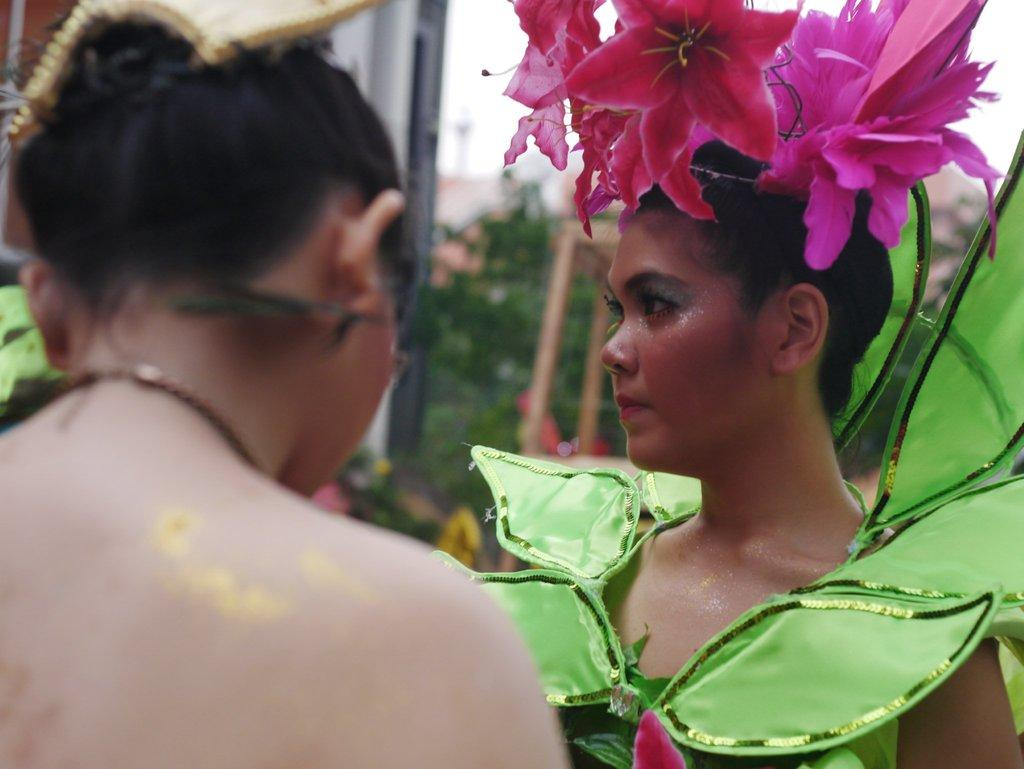What type of people can be seen in the image? There are women standing in the image. What is unique about the appearance of some of the women? Artificial flowers are on the heads of some women. What type of structures are visible in the image? There are buildings visible in the image. What type of vegetation is present in the image? Trees are present in the image. What type of basketball is being played in the image? There is no basketball being played in the image. --- Facts: 1. There is a person in the image. 2. The person is wearing a hat. 3. The person is holding a book. 4. There is a table in the image. 5. There is a chair in the image. Absurd Topics: elephant, piano, ocean Conversation: What is the main subject in the image? There is a person in the image. What is the person wearing on their head? The person is wearing a hat. What is the person holding in their hands? The person is holding a book. What type of furniture is present in the image? There is a table and a chair in the image. Reasoning: Let's think step by step in order to produce the conversation. We start by identifying the main subject of the image, which is the person. Next, we describe specific features of the person, such as the hat. Then, we observe the actions of the person, noting that they are holding a book. Finally, we describe the furniture present in the image, which includes a table and a chair. Absurd Question/Answer: What type of musical instrument can be seen being played in the image? There is no musical instrument being played in the image. --- Facts: 1. There is a group of people in the image. 2. The people are wearing matching outfits. 3. The people are standing in front of a mountain. 4. There is a river flowing in the background. 5. The sky is visible and has a blue color. Absurd Topics: lion, castle, moon Conversation: How many people are present in the image? There is a group of people in the image. What are the people wearing in the image? The people are wearing matching outfits. What type of natural landscape is visible in the image? The people are standing in front of a mountain. What type of water body is present in the background of the image? There is a river flowing in the background. What is the color of the sky visible in the image? The sky is visible and has a blue color. Reasoning: Let's think step by step in order to produce the conversation. We start by identifying the main subject of the image, which is the group of people. Next, we describe specific 